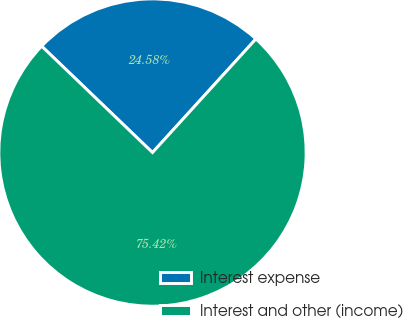Convert chart. <chart><loc_0><loc_0><loc_500><loc_500><pie_chart><fcel>Interest expense<fcel>Interest and other (income)<nl><fcel>24.58%<fcel>75.42%<nl></chart> 